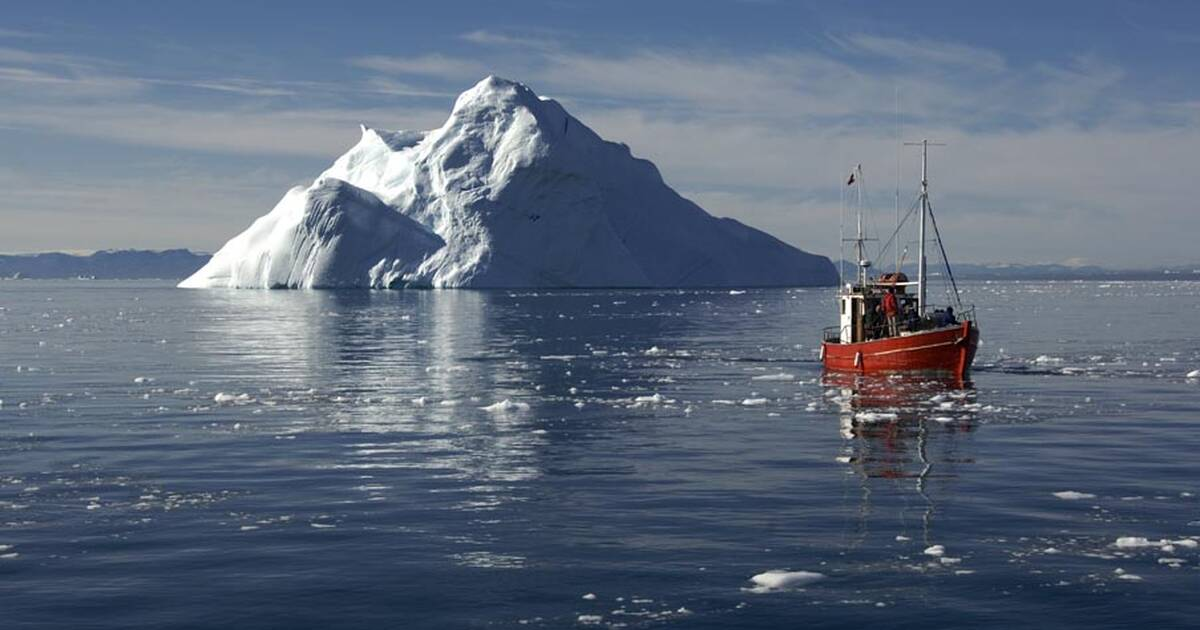Let’s discuss a realistic scenario: A fishing crew navigates their boat through the waters of the Ilulissat Icefjord. What challenges are they likely to face, and how might they overcome them? Navigating the Ilulissat Icefjord presents a myriad of challenges for any fishing crew. The most immediate obstacle is the ice. Large icebergs and scattered ice floes can damage vessels if not carefully avoided. To navigate safely, crews use radar and satellite imagery to track ice movements and plot a course through safer waters. They also rely on the experience and intuition of seasoned ice pilots who know how to read the subtle signs of changing ice conditions.

Another significant challenge is the extreme cold, which can cause engines and other mechanical systems to freeze. Ensuring that the boat is well-maintained and equipped with antifreeze technologies is crucial. Additionally, the crew must wear specialized clothing to protect against hypothermia and frostbite.

The remote location means that communication with the outside world can be limited. Boats must be outfitted with reliable radio and possibly satellite communication systems to stay in touch with rescue services in case of emergencies. Supplies must be carefully managed, and the crew must be well-trained in survival techniques.

Weather conditions can change rapidly, with sudden storms and low visibility becoming major hazards. The crew must stay vigilant, monitoring weather forecasts and being prepared to find sheltered waters if necessary.

Finally, there is the challenge of sustainable fishing practices. Overfishing and environmental preservation are critical concerns. Crews must adhere to strict quotas and use techniques that minimize environmental impact, ensuring that the natural beauty and ecological balance of the Icefjord are maintained. 